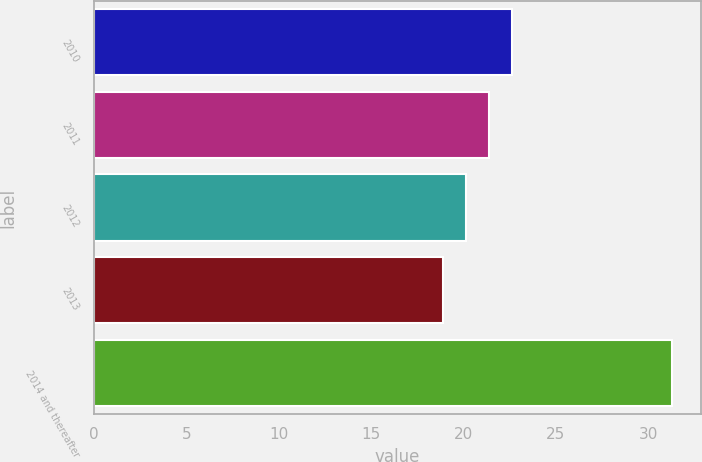<chart> <loc_0><loc_0><loc_500><loc_500><bar_chart><fcel>2010<fcel>2011<fcel>2012<fcel>2013<fcel>2014 and thereafter<nl><fcel>22.62<fcel>21.38<fcel>20.14<fcel>18.9<fcel>31.3<nl></chart> 